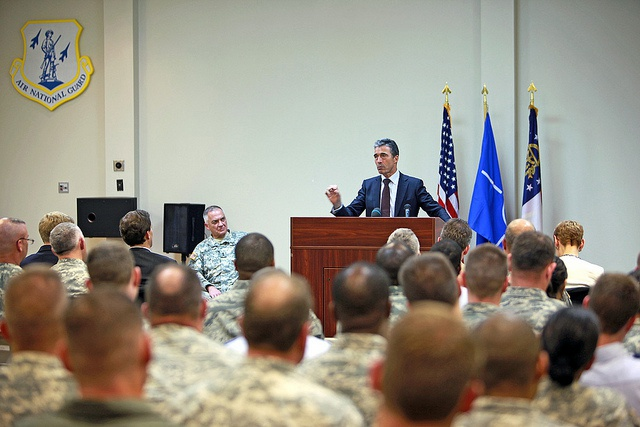Describe the objects in this image and their specific colors. I can see people in darkgreen, darkgray, black, maroon, and lightgray tones, people in darkgreen, tan, beige, and black tones, people in darkgreen, maroon, brown, and gray tones, people in darkgreen, tan, maroon, and gray tones, and people in darkgreen, black, tan, and maroon tones in this image. 